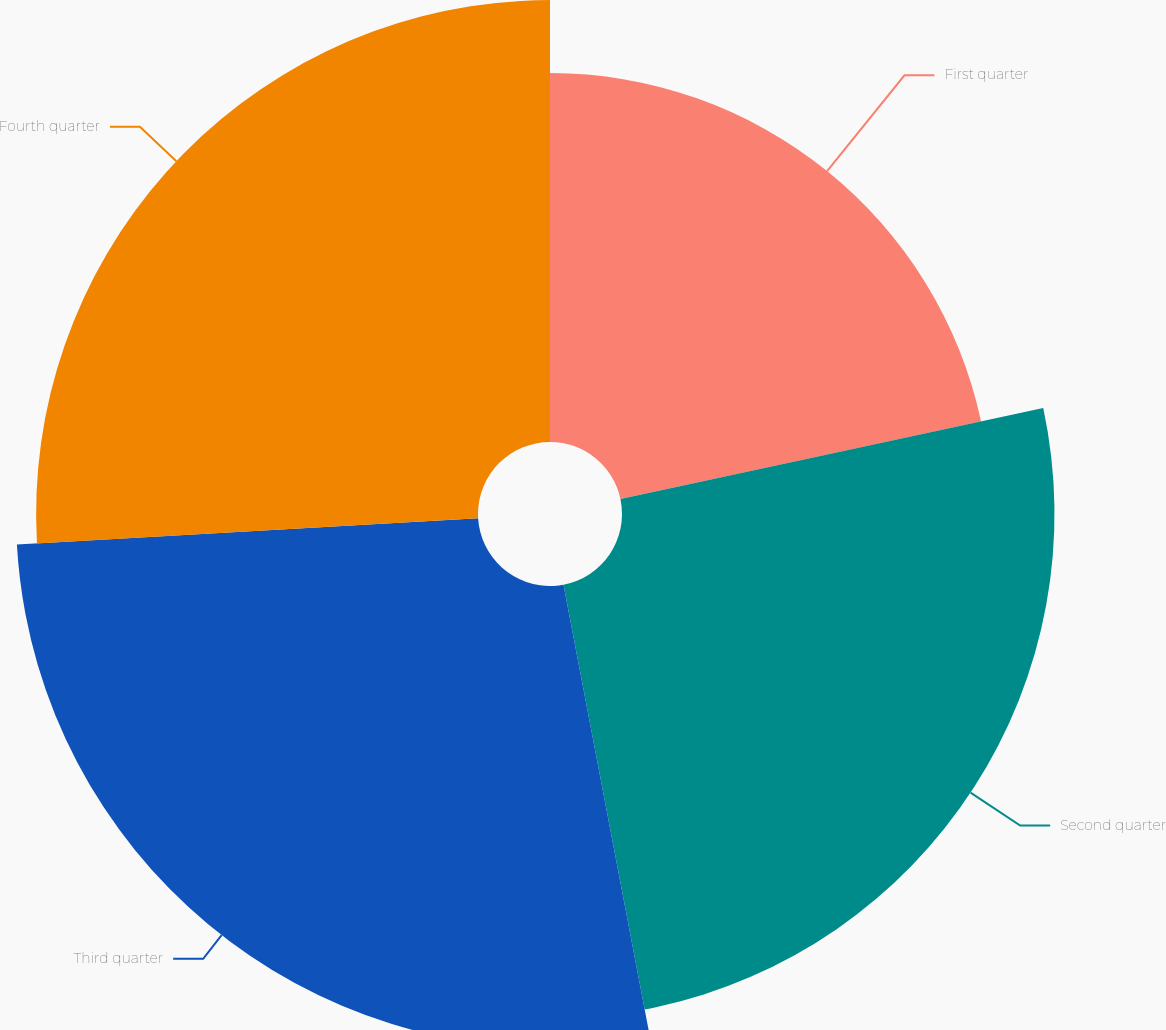<chart> <loc_0><loc_0><loc_500><loc_500><pie_chart><fcel>First quarter<fcel>Second quarter<fcel>Third quarter<fcel>Fourth quarter<nl><fcel>21.63%<fcel>25.36%<fcel>27.09%<fcel>25.91%<nl></chart> 